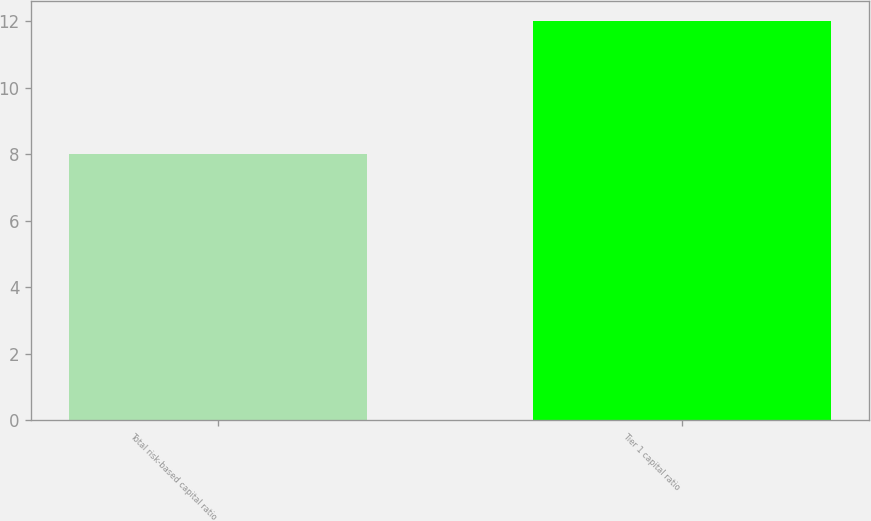Convert chart to OTSL. <chart><loc_0><loc_0><loc_500><loc_500><bar_chart><fcel>Total risk-based capital ratio<fcel>Tier 1 capital ratio<nl><fcel>8<fcel>12<nl></chart> 